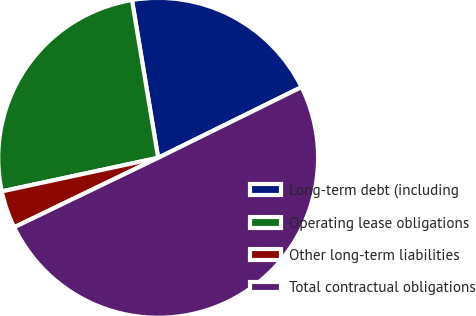<chart> <loc_0><loc_0><loc_500><loc_500><pie_chart><fcel>Long-term debt (including<fcel>Operating lease obligations<fcel>Other long-term liabilities<fcel>Total contractual obligations<nl><fcel>20.33%<fcel>25.75%<fcel>3.79%<fcel>50.14%<nl></chart> 